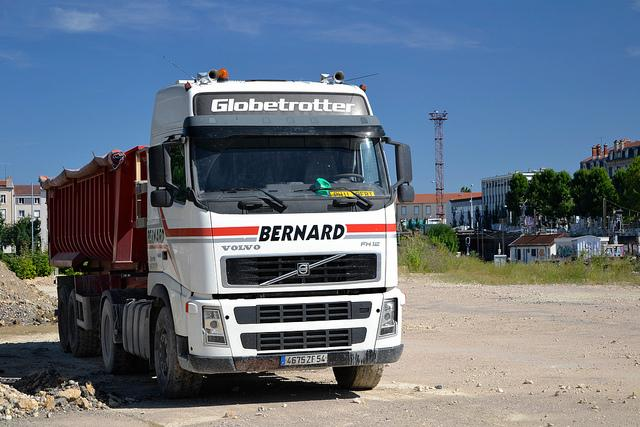This truck shares a name with a popular American Sporting expo group who plays what sport?

Choices:
A) soccer
B) tennis
C) baseball
D) basketball basketball 